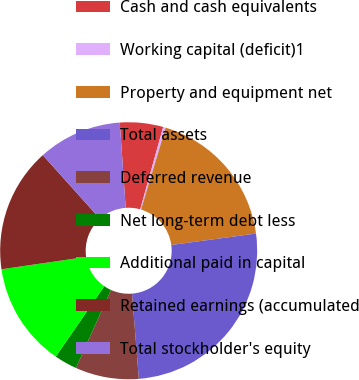Convert chart. <chart><loc_0><loc_0><loc_500><loc_500><pie_chart><fcel>Cash and cash equivalents<fcel>Working capital (deficit)1<fcel>Property and equipment net<fcel>Total assets<fcel>Deferred revenue<fcel>Net long-term debt less<fcel>Additional paid in capital<fcel>Retained earnings (accumulated<fcel>Total stockholder's equity<nl><fcel>5.43%<fcel>0.32%<fcel>18.21%<fcel>25.88%<fcel>7.99%<fcel>2.87%<fcel>13.1%<fcel>15.66%<fcel>10.54%<nl></chart> 